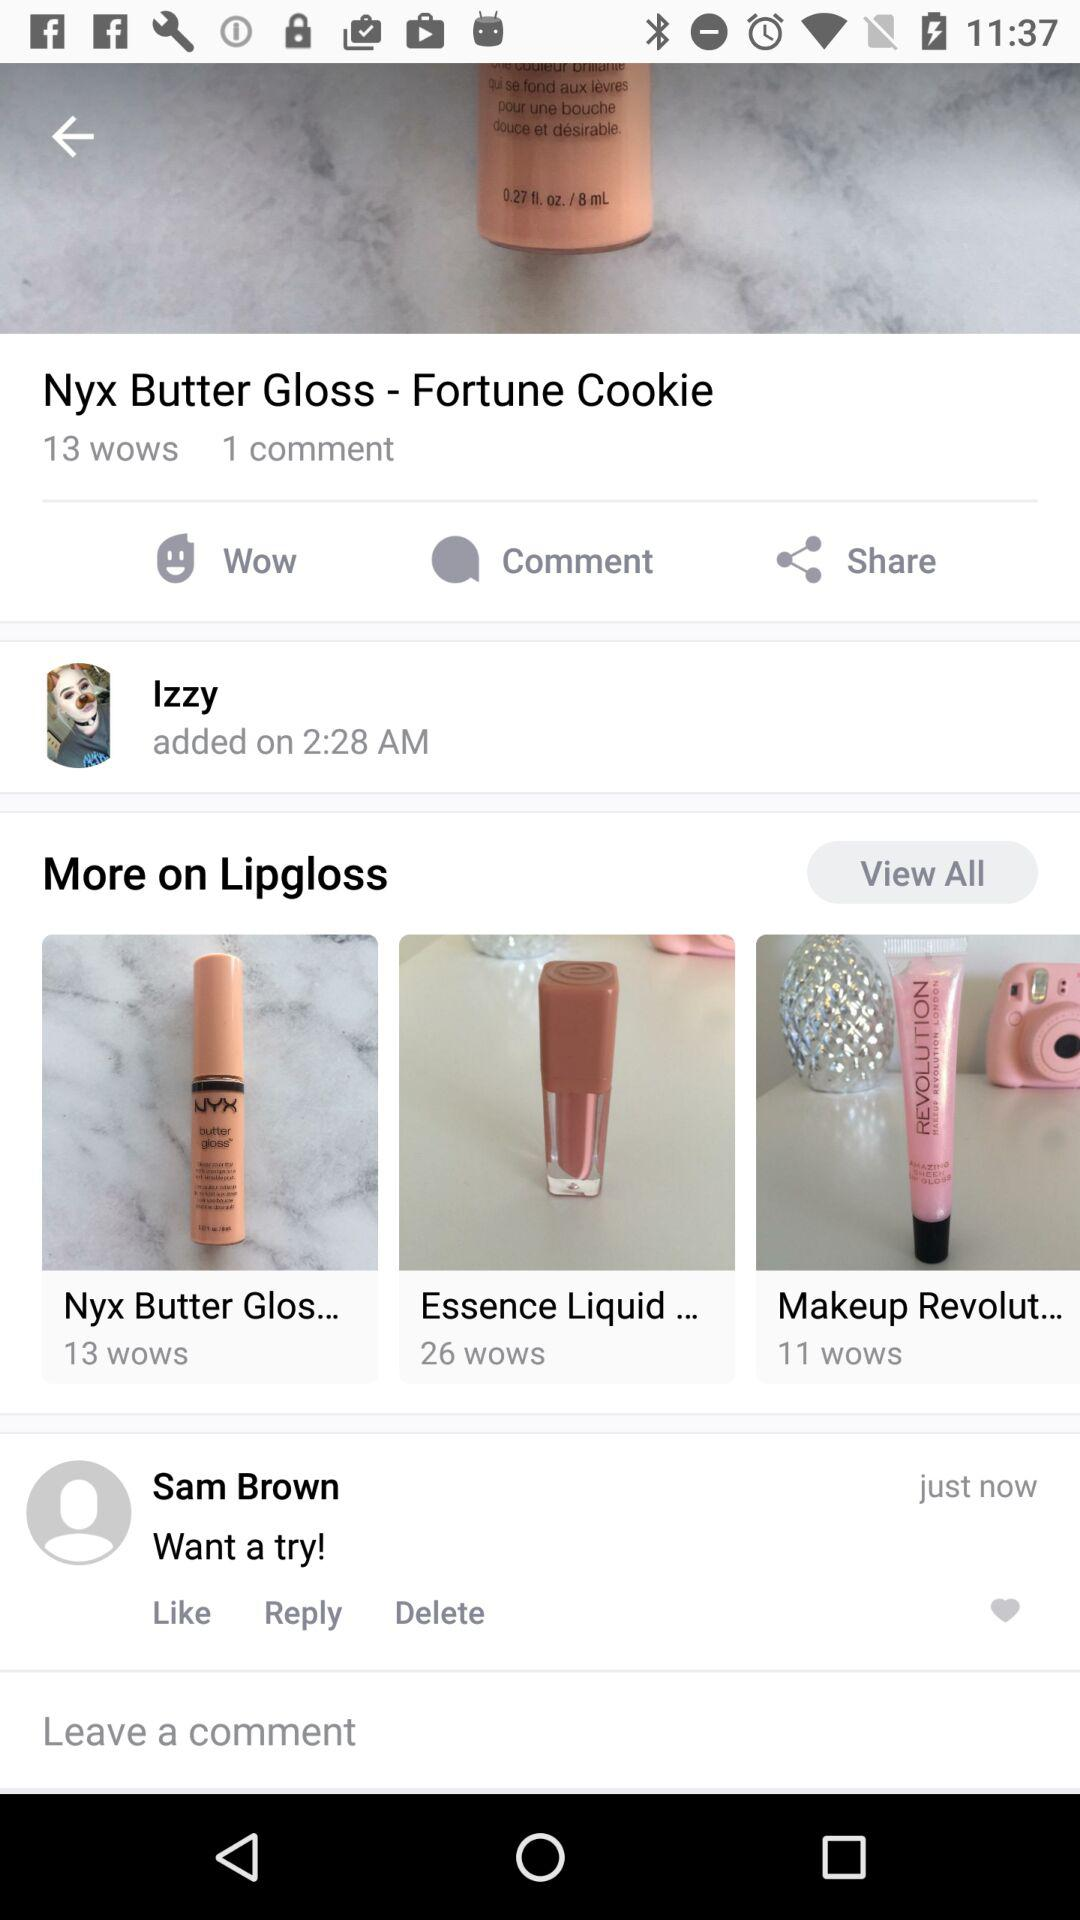How many comments does this post have?
Answer the question using a single word or phrase. 1 